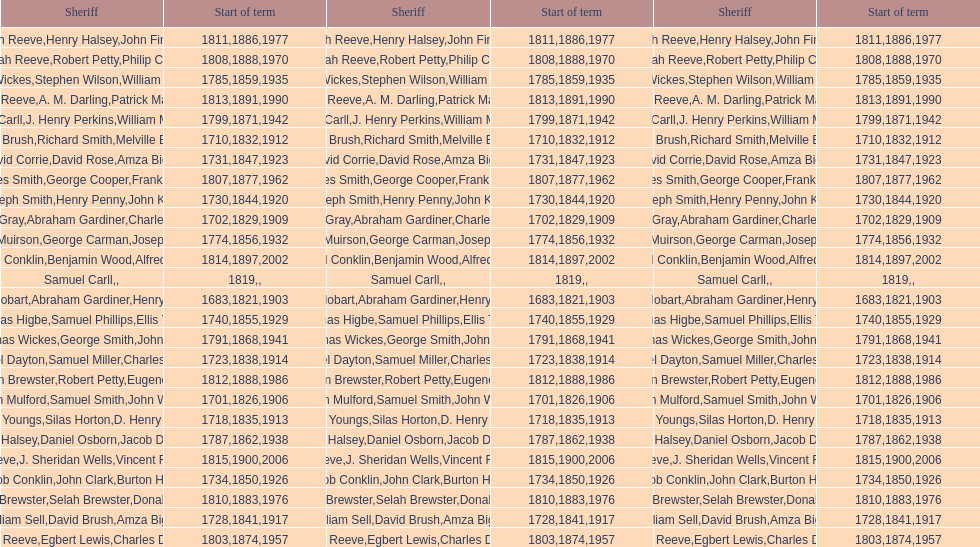Which sheriff came before thomas wickes? James Muirson. 